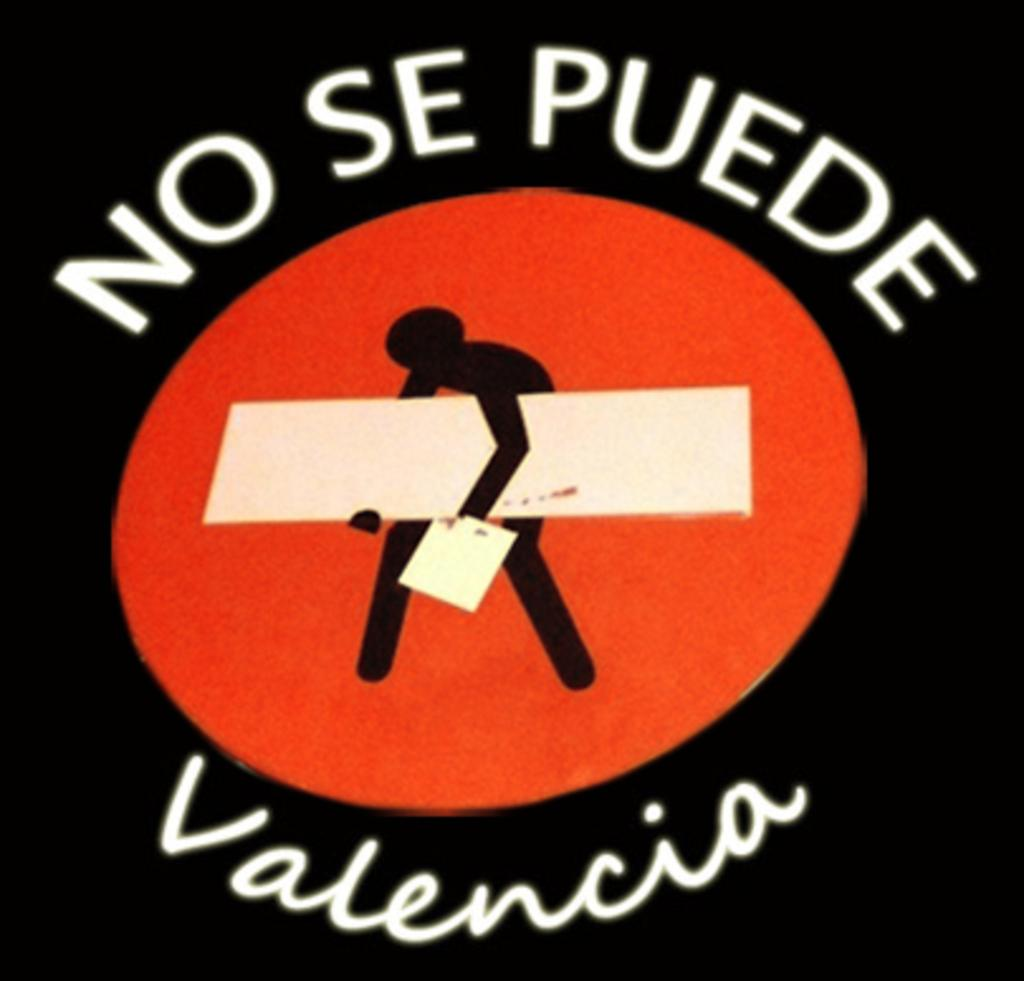<image>
Create a compact narrative representing the image presented. A sign written in mexican is displayed with a black background and a logo. 